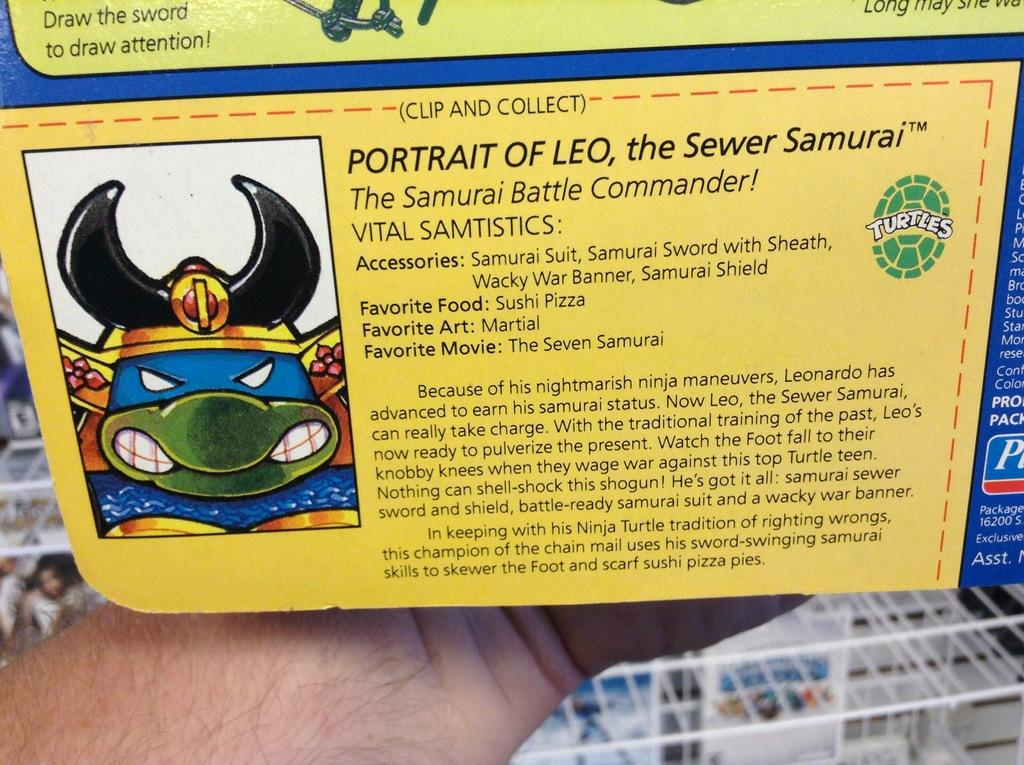What is being held by the person's hand in the image? There is a person's hand holding a card in the image. What is depicted on the card? The card has an animated image on it. What colors are used for the animated image on the card? The animated image is yellow and blue in color. Is there any text on the card? Yes, there is text on the card. What type of voice can be heard coming from the card in the image? There is no voice coming from the card in the image, as it is a static image and not a sound-producing object. 